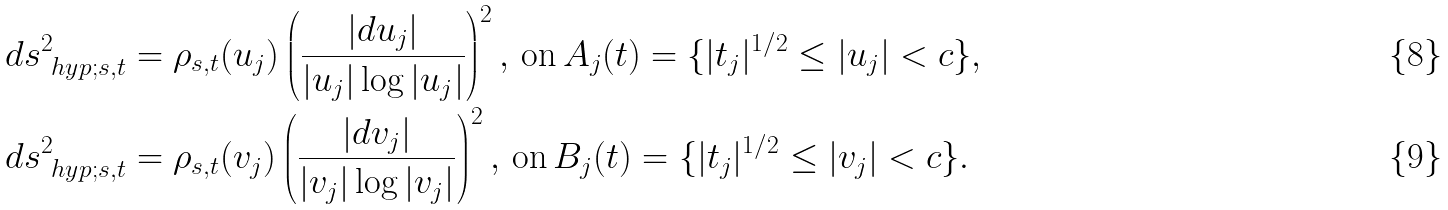Convert formula to latex. <formula><loc_0><loc_0><loc_500><loc_500>& d s _ { \ h y p ; s , t } ^ { 2 } = \rho _ { s , t } ( u _ { j } ) \left ( \frac { | d u _ { j } | } { | u _ { j } | \log | u _ { j } | } \right ) ^ { 2 } , \, \text {on} \, A _ { j } ( t ) = \{ | t _ { j } | ^ { 1 / 2 } \leq | u _ { j } | < c \} , \\ & d s _ { \ h y p ; s , t } ^ { 2 } = \rho _ { s , t } ( v _ { j } ) \left ( \frac { | d v _ { j } | } { | v _ { j } | \log | v _ { j } | } \right ) ^ { 2 } , \, \text {on} \, B _ { j } ( t ) = \{ | t _ { j } | ^ { 1 / 2 } \leq | v _ { j } | < c \} .</formula> 